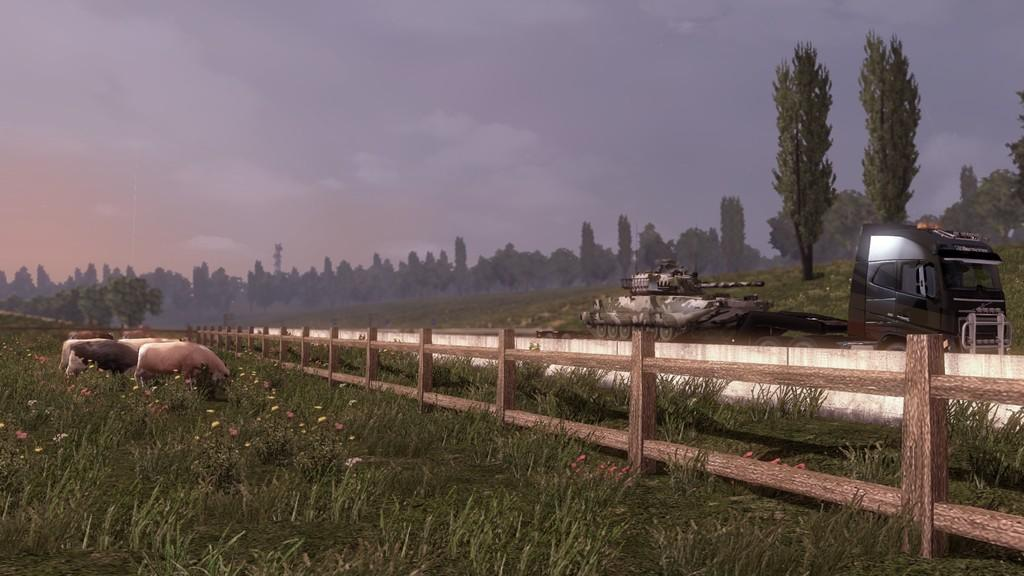What type of barrier can be seen in the image? There is a fence in the image. What else is present in the image besides the fence? There are vehicles, animals, flowers, and grass visible in the image. Can you describe the background of the image? There are trees and the sky visible in the background of the image. What is the condition of the sky in the image? The sky is cloudy in the image. What type of wine is being served at the picnic in the image? There is no picnic or wine present in the image; it features a fence, vehicles, animals, flowers, grass, trees, and a cloudy sky. Can you describe the bird that is flying over the trees in the image? There is no bird present in the image; it only features a fence, vehicles, animals, flowers, grass, trees, and a cloudy sky. 